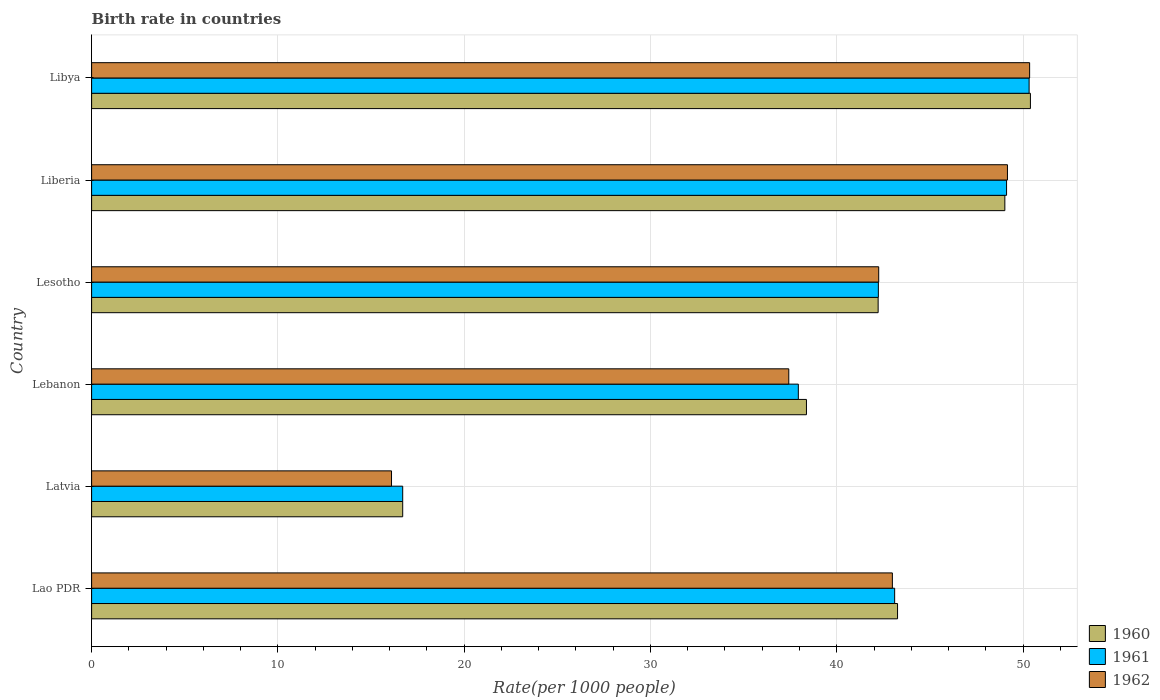How many bars are there on the 3rd tick from the top?
Offer a very short reply. 3. What is the label of the 4th group of bars from the top?
Your answer should be very brief. Lebanon. In how many cases, is the number of bars for a given country not equal to the number of legend labels?
Provide a succinct answer. 0. What is the birth rate in 1962 in Lesotho?
Provide a short and direct response. 42.25. Across all countries, what is the maximum birth rate in 1961?
Give a very brief answer. 50.33. In which country was the birth rate in 1960 maximum?
Provide a succinct answer. Libya. In which country was the birth rate in 1961 minimum?
Provide a succinct answer. Latvia. What is the total birth rate in 1960 in the graph?
Your response must be concise. 239.98. What is the difference between the birth rate in 1962 in Lao PDR and that in Lesotho?
Your response must be concise. 0.73. What is the difference between the birth rate in 1962 in Lesotho and the birth rate in 1961 in Libya?
Offer a terse response. -8.07. What is the average birth rate in 1961 per country?
Provide a succinct answer. 39.9. What is the difference between the birth rate in 1960 and birth rate in 1962 in Lesotho?
Make the answer very short. -0.03. In how many countries, is the birth rate in 1960 greater than 42 ?
Keep it short and to the point. 4. What is the ratio of the birth rate in 1961 in Latvia to that in Lesotho?
Offer a very short reply. 0.4. What is the difference between the highest and the second highest birth rate in 1961?
Your answer should be compact. 1.21. What is the difference between the highest and the lowest birth rate in 1961?
Make the answer very short. 33.63. In how many countries, is the birth rate in 1961 greater than the average birth rate in 1961 taken over all countries?
Give a very brief answer. 4. Is the sum of the birth rate in 1961 in Lao PDR and Lesotho greater than the maximum birth rate in 1962 across all countries?
Your answer should be compact. Yes. What does the 3rd bar from the top in Libya represents?
Your answer should be very brief. 1960. Are all the bars in the graph horizontal?
Provide a succinct answer. Yes. Does the graph contain any zero values?
Your answer should be very brief. No. What is the title of the graph?
Your response must be concise. Birth rate in countries. Does "1997" appear as one of the legend labels in the graph?
Give a very brief answer. No. What is the label or title of the X-axis?
Your answer should be compact. Rate(per 1000 people). What is the label or title of the Y-axis?
Keep it short and to the point. Country. What is the Rate(per 1000 people) in 1960 in Lao PDR?
Provide a succinct answer. 43.26. What is the Rate(per 1000 people) in 1961 in Lao PDR?
Keep it short and to the point. 43.11. What is the Rate(per 1000 people) in 1962 in Lao PDR?
Offer a terse response. 42.99. What is the Rate(per 1000 people) in 1960 in Latvia?
Make the answer very short. 16.7. What is the Rate(per 1000 people) of 1961 in Latvia?
Offer a terse response. 16.7. What is the Rate(per 1000 people) of 1962 in Latvia?
Offer a terse response. 16.1. What is the Rate(per 1000 people) of 1960 in Lebanon?
Give a very brief answer. 38.37. What is the Rate(per 1000 people) of 1961 in Lebanon?
Provide a succinct answer. 37.94. What is the Rate(per 1000 people) of 1962 in Lebanon?
Offer a very short reply. 37.42. What is the Rate(per 1000 people) in 1960 in Lesotho?
Give a very brief answer. 42.22. What is the Rate(per 1000 people) in 1961 in Lesotho?
Your answer should be compact. 42.23. What is the Rate(per 1000 people) in 1962 in Lesotho?
Offer a very short reply. 42.25. What is the Rate(per 1000 people) in 1960 in Liberia?
Your answer should be very brief. 49.02. What is the Rate(per 1000 people) of 1961 in Liberia?
Make the answer very short. 49.12. What is the Rate(per 1000 people) of 1962 in Liberia?
Offer a very short reply. 49.16. What is the Rate(per 1000 people) in 1960 in Libya?
Provide a succinct answer. 50.4. What is the Rate(per 1000 people) of 1961 in Libya?
Provide a succinct answer. 50.33. What is the Rate(per 1000 people) of 1962 in Libya?
Give a very brief answer. 50.35. Across all countries, what is the maximum Rate(per 1000 people) in 1960?
Provide a succinct answer. 50.4. Across all countries, what is the maximum Rate(per 1000 people) of 1961?
Provide a short and direct response. 50.33. Across all countries, what is the maximum Rate(per 1000 people) of 1962?
Give a very brief answer. 50.35. Across all countries, what is the minimum Rate(per 1000 people) of 1962?
Your response must be concise. 16.1. What is the total Rate(per 1000 people) of 1960 in the graph?
Your response must be concise. 239.98. What is the total Rate(per 1000 people) in 1961 in the graph?
Offer a terse response. 239.42. What is the total Rate(per 1000 people) of 1962 in the graph?
Provide a succinct answer. 238.28. What is the difference between the Rate(per 1000 people) of 1960 in Lao PDR and that in Latvia?
Make the answer very short. 26.56. What is the difference between the Rate(per 1000 people) of 1961 in Lao PDR and that in Latvia?
Ensure brevity in your answer.  26.41. What is the difference between the Rate(per 1000 people) of 1962 in Lao PDR and that in Latvia?
Offer a terse response. 26.89. What is the difference between the Rate(per 1000 people) of 1960 in Lao PDR and that in Lebanon?
Your answer should be very brief. 4.89. What is the difference between the Rate(per 1000 people) in 1961 in Lao PDR and that in Lebanon?
Ensure brevity in your answer.  5.17. What is the difference between the Rate(per 1000 people) in 1962 in Lao PDR and that in Lebanon?
Keep it short and to the point. 5.56. What is the difference between the Rate(per 1000 people) in 1960 in Lao PDR and that in Lesotho?
Your answer should be compact. 1.04. What is the difference between the Rate(per 1000 people) of 1961 in Lao PDR and that in Lesotho?
Offer a terse response. 0.88. What is the difference between the Rate(per 1000 people) in 1962 in Lao PDR and that in Lesotho?
Give a very brief answer. 0.73. What is the difference between the Rate(per 1000 people) of 1960 in Lao PDR and that in Liberia?
Offer a very short reply. -5.76. What is the difference between the Rate(per 1000 people) of 1961 in Lao PDR and that in Liberia?
Make the answer very short. -6.01. What is the difference between the Rate(per 1000 people) of 1962 in Lao PDR and that in Liberia?
Offer a very short reply. -6.18. What is the difference between the Rate(per 1000 people) of 1960 in Lao PDR and that in Libya?
Make the answer very short. -7.13. What is the difference between the Rate(per 1000 people) in 1961 in Lao PDR and that in Libya?
Keep it short and to the point. -7.22. What is the difference between the Rate(per 1000 people) in 1962 in Lao PDR and that in Libya?
Your answer should be compact. -7.37. What is the difference between the Rate(per 1000 people) in 1960 in Latvia and that in Lebanon?
Your answer should be compact. -21.67. What is the difference between the Rate(per 1000 people) of 1961 in Latvia and that in Lebanon?
Ensure brevity in your answer.  -21.24. What is the difference between the Rate(per 1000 people) in 1962 in Latvia and that in Lebanon?
Give a very brief answer. -21.32. What is the difference between the Rate(per 1000 people) of 1960 in Latvia and that in Lesotho?
Provide a short and direct response. -25.52. What is the difference between the Rate(per 1000 people) of 1961 in Latvia and that in Lesotho?
Keep it short and to the point. -25.53. What is the difference between the Rate(per 1000 people) in 1962 in Latvia and that in Lesotho?
Provide a succinct answer. -26.15. What is the difference between the Rate(per 1000 people) of 1960 in Latvia and that in Liberia?
Give a very brief answer. -32.32. What is the difference between the Rate(per 1000 people) in 1961 in Latvia and that in Liberia?
Offer a terse response. -32.42. What is the difference between the Rate(per 1000 people) in 1962 in Latvia and that in Liberia?
Offer a terse response. -33.06. What is the difference between the Rate(per 1000 people) of 1960 in Latvia and that in Libya?
Your response must be concise. -33.7. What is the difference between the Rate(per 1000 people) of 1961 in Latvia and that in Libya?
Offer a very short reply. -33.63. What is the difference between the Rate(per 1000 people) in 1962 in Latvia and that in Libya?
Provide a short and direct response. -34.25. What is the difference between the Rate(per 1000 people) of 1960 in Lebanon and that in Lesotho?
Provide a succinct answer. -3.85. What is the difference between the Rate(per 1000 people) of 1961 in Lebanon and that in Lesotho?
Make the answer very short. -4.3. What is the difference between the Rate(per 1000 people) of 1962 in Lebanon and that in Lesotho?
Offer a very short reply. -4.83. What is the difference between the Rate(per 1000 people) of 1960 in Lebanon and that in Liberia?
Your answer should be compact. -10.65. What is the difference between the Rate(per 1000 people) in 1961 in Lebanon and that in Liberia?
Your response must be concise. -11.18. What is the difference between the Rate(per 1000 people) of 1962 in Lebanon and that in Liberia?
Provide a succinct answer. -11.74. What is the difference between the Rate(per 1000 people) in 1960 in Lebanon and that in Libya?
Keep it short and to the point. -12.02. What is the difference between the Rate(per 1000 people) in 1961 in Lebanon and that in Libya?
Provide a short and direct response. -12.39. What is the difference between the Rate(per 1000 people) of 1962 in Lebanon and that in Libya?
Your answer should be compact. -12.93. What is the difference between the Rate(per 1000 people) of 1960 in Lesotho and that in Liberia?
Provide a succinct answer. -6.8. What is the difference between the Rate(per 1000 people) in 1961 in Lesotho and that in Liberia?
Keep it short and to the point. -6.88. What is the difference between the Rate(per 1000 people) in 1962 in Lesotho and that in Liberia?
Your answer should be very brief. -6.91. What is the difference between the Rate(per 1000 people) in 1960 in Lesotho and that in Libya?
Make the answer very short. -8.18. What is the difference between the Rate(per 1000 people) in 1961 in Lesotho and that in Libya?
Provide a short and direct response. -8.09. What is the difference between the Rate(per 1000 people) in 1962 in Lesotho and that in Libya?
Provide a short and direct response. -8.1. What is the difference between the Rate(per 1000 people) of 1960 in Liberia and that in Libya?
Your answer should be very brief. -1.37. What is the difference between the Rate(per 1000 people) of 1961 in Liberia and that in Libya?
Ensure brevity in your answer.  -1.21. What is the difference between the Rate(per 1000 people) of 1962 in Liberia and that in Libya?
Offer a terse response. -1.19. What is the difference between the Rate(per 1000 people) in 1960 in Lao PDR and the Rate(per 1000 people) in 1961 in Latvia?
Provide a succinct answer. 26.56. What is the difference between the Rate(per 1000 people) in 1960 in Lao PDR and the Rate(per 1000 people) in 1962 in Latvia?
Provide a short and direct response. 27.16. What is the difference between the Rate(per 1000 people) in 1961 in Lao PDR and the Rate(per 1000 people) in 1962 in Latvia?
Offer a terse response. 27.01. What is the difference between the Rate(per 1000 people) of 1960 in Lao PDR and the Rate(per 1000 people) of 1961 in Lebanon?
Offer a very short reply. 5.33. What is the difference between the Rate(per 1000 people) of 1960 in Lao PDR and the Rate(per 1000 people) of 1962 in Lebanon?
Provide a short and direct response. 5.84. What is the difference between the Rate(per 1000 people) in 1961 in Lao PDR and the Rate(per 1000 people) in 1962 in Lebanon?
Your response must be concise. 5.68. What is the difference between the Rate(per 1000 people) of 1961 in Lao PDR and the Rate(per 1000 people) of 1962 in Lesotho?
Your response must be concise. 0.86. What is the difference between the Rate(per 1000 people) in 1960 in Lao PDR and the Rate(per 1000 people) in 1961 in Liberia?
Offer a very short reply. -5.85. What is the difference between the Rate(per 1000 people) in 1961 in Lao PDR and the Rate(per 1000 people) in 1962 in Liberia?
Provide a short and direct response. -6.05. What is the difference between the Rate(per 1000 people) in 1960 in Lao PDR and the Rate(per 1000 people) in 1961 in Libya?
Ensure brevity in your answer.  -7.06. What is the difference between the Rate(per 1000 people) in 1960 in Lao PDR and the Rate(per 1000 people) in 1962 in Libya?
Provide a succinct answer. -7.09. What is the difference between the Rate(per 1000 people) of 1961 in Lao PDR and the Rate(per 1000 people) of 1962 in Libya?
Your answer should be very brief. -7.25. What is the difference between the Rate(per 1000 people) in 1960 in Latvia and the Rate(per 1000 people) in 1961 in Lebanon?
Make the answer very short. -21.24. What is the difference between the Rate(per 1000 people) of 1960 in Latvia and the Rate(per 1000 people) of 1962 in Lebanon?
Your answer should be very brief. -20.73. What is the difference between the Rate(per 1000 people) in 1961 in Latvia and the Rate(per 1000 people) in 1962 in Lebanon?
Ensure brevity in your answer.  -20.73. What is the difference between the Rate(per 1000 people) in 1960 in Latvia and the Rate(per 1000 people) in 1961 in Lesotho?
Your answer should be very brief. -25.53. What is the difference between the Rate(per 1000 people) of 1960 in Latvia and the Rate(per 1000 people) of 1962 in Lesotho?
Give a very brief answer. -25.55. What is the difference between the Rate(per 1000 people) of 1961 in Latvia and the Rate(per 1000 people) of 1962 in Lesotho?
Keep it short and to the point. -25.55. What is the difference between the Rate(per 1000 people) in 1960 in Latvia and the Rate(per 1000 people) in 1961 in Liberia?
Offer a terse response. -32.42. What is the difference between the Rate(per 1000 people) of 1960 in Latvia and the Rate(per 1000 people) of 1962 in Liberia?
Your answer should be very brief. -32.46. What is the difference between the Rate(per 1000 people) in 1961 in Latvia and the Rate(per 1000 people) in 1962 in Liberia?
Your answer should be very brief. -32.46. What is the difference between the Rate(per 1000 people) of 1960 in Latvia and the Rate(per 1000 people) of 1961 in Libya?
Offer a very short reply. -33.63. What is the difference between the Rate(per 1000 people) in 1960 in Latvia and the Rate(per 1000 people) in 1962 in Libya?
Provide a succinct answer. -33.65. What is the difference between the Rate(per 1000 people) in 1961 in Latvia and the Rate(per 1000 people) in 1962 in Libya?
Your answer should be very brief. -33.65. What is the difference between the Rate(per 1000 people) in 1960 in Lebanon and the Rate(per 1000 people) in 1961 in Lesotho?
Provide a short and direct response. -3.86. What is the difference between the Rate(per 1000 people) in 1960 in Lebanon and the Rate(per 1000 people) in 1962 in Lesotho?
Your answer should be very brief. -3.88. What is the difference between the Rate(per 1000 people) in 1961 in Lebanon and the Rate(per 1000 people) in 1962 in Lesotho?
Ensure brevity in your answer.  -4.31. What is the difference between the Rate(per 1000 people) in 1960 in Lebanon and the Rate(per 1000 people) in 1961 in Liberia?
Provide a short and direct response. -10.74. What is the difference between the Rate(per 1000 people) in 1960 in Lebanon and the Rate(per 1000 people) in 1962 in Liberia?
Keep it short and to the point. -10.79. What is the difference between the Rate(per 1000 people) in 1961 in Lebanon and the Rate(per 1000 people) in 1962 in Liberia?
Your answer should be compact. -11.23. What is the difference between the Rate(per 1000 people) in 1960 in Lebanon and the Rate(per 1000 people) in 1961 in Libya?
Your answer should be compact. -11.95. What is the difference between the Rate(per 1000 people) of 1960 in Lebanon and the Rate(per 1000 people) of 1962 in Libya?
Your answer should be very brief. -11.98. What is the difference between the Rate(per 1000 people) of 1961 in Lebanon and the Rate(per 1000 people) of 1962 in Libya?
Provide a succinct answer. -12.42. What is the difference between the Rate(per 1000 people) in 1960 in Lesotho and the Rate(per 1000 people) in 1961 in Liberia?
Offer a very short reply. -6.89. What is the difference between the Rate(per 1000 people) of 1960 in Lesotho and the Rate(per 1000 people) of 1962 in Liberia?
Your answer should be compact. -6.94. What is the difference between the Rate(per 1000 people) in 1961 in Lesotho and the Rate(per 1000 people) in 1962 in Liberia?
Give a very brief answer. -6.93. What is the difference between the Rate(per 1000 people) of 1960 in Lesotho and the Rate(per 1000 people) of 1961 in Libya?
Keep it short and to the point. -8.1. What is the difference between the Rate(per 1000 people) in 1960 in Lesotho and the Rate(per 1000 people) in 1962 in Libya?
Your answer should be compact. -8.13. What is the difference between the Rate(per 1000 people) in 1961 in Lesotho and the Rate(per 1000 people) in 1962 in Libya?
Ensure brevity in your answer.  -8.12. What is the difference between the Rate(per 1000 people) of 1960 in Liberia and the Rate(per 1000 people) of 1961 in Libya?
Make the answer very short. -1.3. What is the difference between the Rate(per 1000 people) of 1960 in Liberia and the Rate(per 1000 people) of 1962 in Libya?
Provide a succinct answer. -1.33. What is the difference between the Rate(per 1000 people) in 1961 in Liberia and the Rate(per 1000 people) in 1962 in Libya?
Keep it short and to the point. -1.24. What is the average Rate(per 1000 people) in 1960 per country?
Ensure brevity in your answer.  40. What is the average Rate(per 1000 people) in 1961 per country?
Ensure brevity in your answer.  39.9. What is the average Rate(per 1000 people) in 1962 per country?
Your answer should be very brief. 39.71. What is the difference between the Rate(per 1000 people) of 1960 and Rate(per 1000 people) of 1961 in Lao PDR?
Keep it short and to the point. 0.15. What is the difference between the Rate(per 1000 people) in 1960 and Rate(per 1000 people) in 1962 in Lao PDR?
Offer a very short reply. 0.28. What is the difference between the Rate(per 1000 people) in 1961 and Rate(per 1000 people) in 1962 in Lao PDR?
Give a very brief answer. 0.12. What is the difference between the Rate(per 1000 people) of 1960 and Rate(per 1000 people) of 1961 in Latvia?
Offer a terse response. 0. What is the difference between the Rate(per 1000 people) of 1960 and Rate(per 1000 people) of 1962 in Latvia?
Keep it short and to the point. 0.6. What is the difference between the Rate(per 1000 people) in 1961 and Rate(per 1000 people) in 1962 in Latvia?
Provide a short and direct response. 0.6. What is the difference between the Rate(per 1000 people) of 1960 and Rate(per 1000 people) of 1961 in Lebanon?
Provide a succinct answer. 0.44. What is the difference between the Rate(per 1000 people) in 1960 and Rate(per 1000 people) in 1962 in Lebanon?
Give a very brief answer. 0.95. What is the difference between the Rate(per 1000 people) of 1961 and Rate(per 1000 people) of 1962 in Lebanon?
Your answer should be very brief. 0.51. What is the difference between the Rate(per 1000 people) of 1960 and Rate(per 1000 people) of 1961 in Lesotho?
Make the answer very short. -0.01. What is the difference between the Rate(per 1000 people) in 1960 and Rate(per 1000 people) in 1962 in Lesotho?
Your response must be concise. -0.03. What is the difference between the Rate(per 1000 people) of 1961 and Rate(per 1000 people) of 1962 in Lesotho?
Offer a terse response. -0.02. What is the difference between the Rate(per 1000 people) in 1960 and Rate(per 1000 people) in 1961 in Liberia?
Give a very brief answer. -0.09. What is the difference between the Rate(per 1000 people) in 1960 and Rate(per 1000 people) in 1962 in Liberia?
Provide a short and direct response. -0.14. What is the difference between the Rate(per 1000 people) in 1961 and Rate(per 1000 people) in 1962 in Liberia?
Offer a terse response. -0.05. What is the difference between the Rate(per 1000 people) in 1960 and Rate(per 1000 people) in 1961 in Libya?
Your answer should be very brief. 0.07. What is the difference between the Rate(per 1000 people) of 1960 and Rate(per 1000 people) of 1962 in Libya?
Your answer should be very brief. 0.04. What is the difference between the Rate(per 1000 people) of 1961 and Rate(per 1000 people) of 1962 in Libya?
Your answer should be compact. -0.03. What is the ratio of the Rate(per 1000 people) in 1960 in Lao PDR to that in Latvia?
Offer a very short reply. 2.59. What is the ratio of the Rate(per 1000 people) of 1961 in Lao PDR to that in Latvia?
Your answer should be very brief. 2.58. What is the ratio of the Rate(per 1000 people) in 1962 in Lao PDR to that in Latvia?
Your response must be concise. 2.67. What is the ratio of the Rate(per 1000 people) of 1960 in Lao PDR to that in Lebanon?
Provide a succinct answer. 1.13. What is the ratio of the Rate(per 1000 people) in 1961 in Lao PDR to that in Lebanon?
Ensure brevity in your answer.  1.14. What is the ratio of the Rate(per 1000 people) in 1962 in Lao PDR to that in Lebanon?
Provide a short and direct response. 1.15. What is the ratio of the Rate(per 1000 people) in 1960 in Lao PDR to that in Lesotho?
Provide a short and direct response. 1.02. What is the ratio of the Rate(per 1000 people) in 1961 in Lao PDR to that in Lesotho?
Your answer should be very brief. 1.02. What is the ratio of the Rate(per 1000 people) of 1962 in Lao PDR to that in Lesotho?
Make the answer very short. 1.02. What is the ratio of the Rate(per 1000 people) in 1960 in Lao PDR to that in Liberia?
Provide a short and direct response. 0.88. What is the ratio of the Rate(per 1000 people) in 1961 in Lao PDR to that in Liberia?
Make the answer very short. 0.88. What is the ratio of the Rate(per 1000 people) in 1962 in Lao PDR to that in Liberia?
Keep it short and to the point. 0.87. What is the ratio of the Rate(per 1000 people) of 1960 in Lao PDR to that in Libya?
Provide a short and direct response. 0.86. What is the ratio of the Rate(per 1000 people) in 1961 in Lao PDR to that in Libya?
Offer a very short reply. 0.86. What is the ratio of the Rate(per 1000 people) in 1962 in Lao PDR to that in Libya?
Provide a short and direct response. 0.85. What is the ratio of the Rate(per 1000 people) in 1960 in Latvia to that in Lebanon?
Your answer should be compact. 0.44. What is the ratio of the Rate(per 1000 people) of 1961 in Latvia to that in Lebanon?
Ensure brevity in your answer.  0.44. What is the ratio of the Rate(per 1000 people) of 1962 in Latvia to that in Lebanon?
Provide a succinct answer. 0.43. What is the ratio of the Rate(per 1000 people) of 1960 in Latvia to that in Lesotho?
Make the answer very short. 0.4. What is the ratio of the Rate(per 1000 people) in 1961 in Latvia to that in Lesotho?
Your response must be concise. 0.4. What is the ratio of the Rate(per 1000 people) in 1962 in Latvia to that in Lesotho?
Provide a succinct answer. 0.38. What is the ratio of the Rate(per 1000 people) in 1960 in Latvia to that in Liberia?
Provide a succinct answer. 0.34. What is the ratio of the Rate(per 1000 people) in 1961 in Latvia to that in Liberia?
Your response must be concise. 0.34. What is the ratio of the Rate(per 1000 people) in 1962 in Latvia to that in Liberia?
Offer a terse response. 0.33. What is the ratio of the Rate(per 1000 people) in 1960 in Latvia to that in Libya?
Ensure brevity in your answer.  0.33. What is the ratio of the Rate(per 1000 people) in 1961 in Latvia to that in Libya?
Keep it short and to the point. 0.33. What is the ratio of the Rate(per 1000 people) of 1962 in Latvia to that in Libya?
Keep it short and to the point. 0.32. What is the ratio of the Rate(per 1000 people) in 1960 in Lebanon to that in Lesotho?
Provide a succinct answer. 0.91. What is the ratio of the Rate(per 1000 people) of 1961 in Lebanon to that in Lesotho?
Give a very brief answer. 0.9. What is the ratio of the Rate(per 1000 people) of 1962 in Lebanon to that in Lesotho?
Provide a short and direct response. 0.89. What is the ratio of the Rate(per 1000 people) of 1960 in Lebanon to that in Liberia?
Ensure brevity in your answer.  0.78. What is the ratio of the Rate(per 1000 people) of 1961 in Lebanon to that in Liberia?
Make the answer very short. 0.77. What is the ratio of the Rate(per 1000 people) in 1962 in Lebanon to that in Liberia?
Make the answer very short. 0.76. What is the ratio of the Rate(per 1000 people) of 1960 in Lebanon to that in Libya?
Make the answer very short. 0.76. What is the ratio of the Rate(per 1000 people) of 1961 in Lebanon to that in Libya?
Your answer should be compact. 0.75. What is the ratio of the Rate(per 1000 people) in 1962 in Lebanon to that in Libya?
Ensure brevity in your answer.  0.74. What is the ratio of the Rate(per 1000 people) of 1960 in Lesotho to that in Liberia?
Your answer should be compact. 0.86. What is the ratio of the Rate(per 1000 people) in 1961 in Lesotho to that in Liberia?
Make the answer very short. 0.86. What is the ratio of the Rate(per 1000 people) in 1962 in Lesotho to that in Liberia?
Your answer should be compact. 0.86. What is the ratio of the Rate(per 1000 people) in 1960 in Lesotho to that in Libya?
Ensure brevity in your answer.  0.84. What is the ratio of the Rate(per 1000 people) of 1961 in Lesotho to that in Libya?
Your answer should be very brief. 0.84. What is the ratio of the Rate(per 1000 people) in 1962 in Lesotho to that in Libya?
Offer a very short reply. 0.84. What is the ratio of the Rate(per 1000 people) of 1960 in Liberia to that in Libya?
Provide a succinct answer. 0.97. What is the ratio of the Rate(per 1000 people) in 1962 in Liberia to that in Libya?
Provide a succinct answer. 0.98. What is the difference between the highest and the second highest Rate(per 1000 people) in 1960?
Provide a succinct answer. 1.37. What is the difference between the highest and the second highest Rate(per 1000 people) in 1961?
Your answer should be compact. 1.21. What is the difference between the highest and the second highest Rate(per 1000 people) of 1962?
Make the answer very short. 1.19. What is the difference between the highest and the lowest Rate(per 1000 people) of 1960?
Your answer should be compact. 33.7. What is the difference between the highest and the lowest Rate(per 1000 people) of 1961?
Your answer should be very brief. 33.63. What is the difference between the highest and the lowest Rate(per 1000 people) in 1962?
Your answer should be compact. 34.25. 